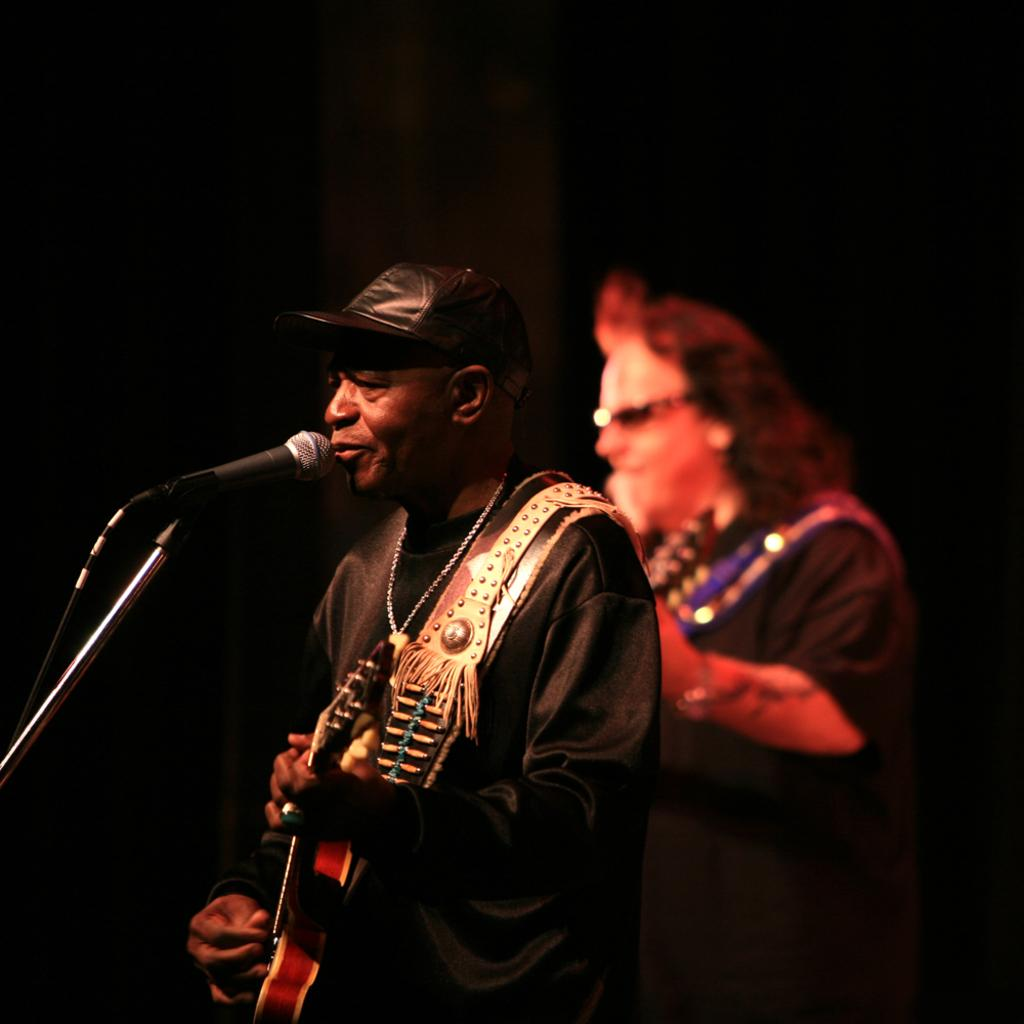How many people are in the image? There are two men in the image. What are the men doing in the image? Both men are holding musical instruments. Can you describe the position of one of the men in the image? One of the men is in front of a mic. What type of drug can be seen in the image? There is no drug present in the image. How many matches are visible in the image? There are no matches visible in the image. 